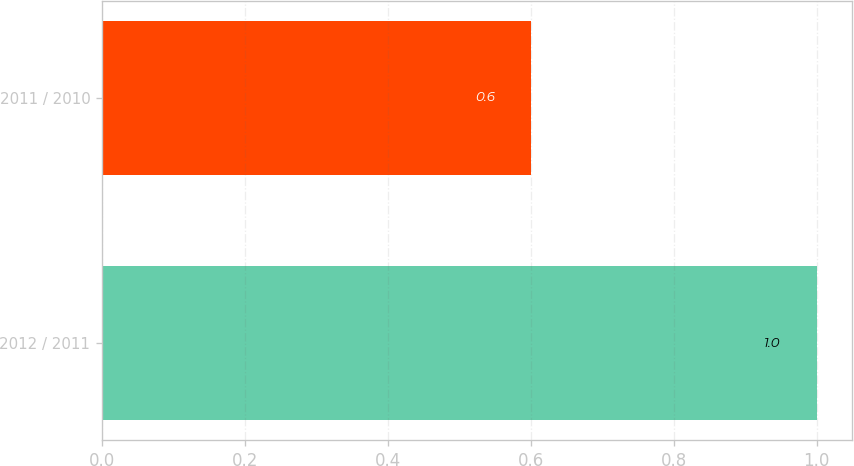Convert chart. <chart><loc_0><loc_0><loc_500><loc_500><bar_chart><fcel>2012 / 2011<fcel>2011 / 2010<nl><fcel>1<fcel>0.6<nl></chart> 